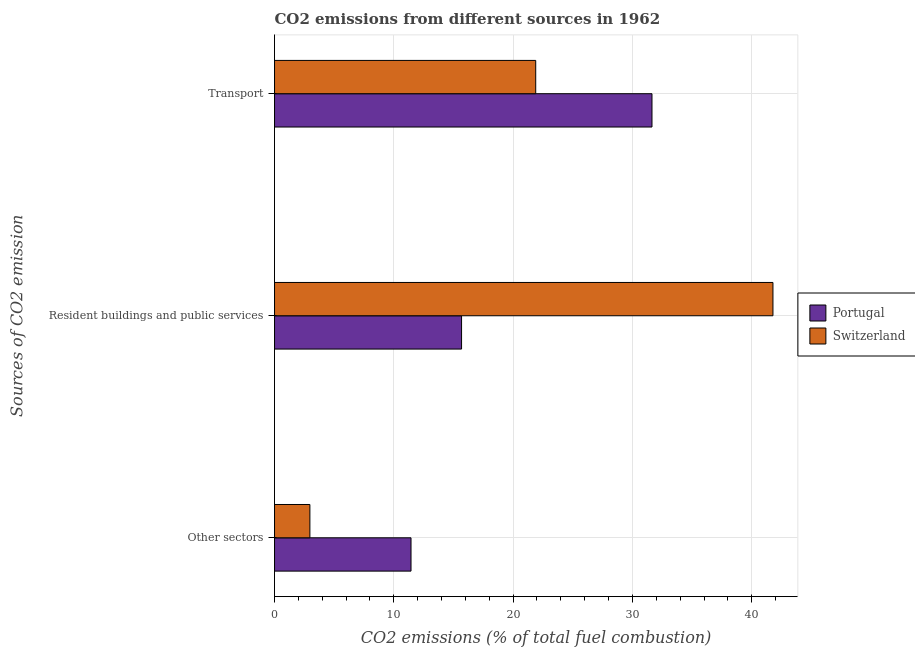Are the number of bars on each tick of the Y-axis equal?
Your answer should be compact. Yes. What is the label of the 3rd group of bars from the top?
Your answer should be compact. Other sectors. What is the percentage of co2 emissions from resident buildings and public services in Portugal?
Ensure brevity in your answer.  15.68. Across all countries, what is the maximum percentage of co2 emissions from other sectors?
Provide a succinct answer. 11.44. Across all countries, what is the minimum percentage of co2 emissions from resident buildings and public services?
Your answer should be very brief. 15.68. In which country was the percentage of co2 emissions from resident buildings and public services maximum?
Offer a terse response. Switzerland. In which country was the percentage of co2 emissions from transport minimum?
Provide a succinct answer. Switzerland. What is the total percentage of co2 emissions from other sectors in the graph?
Your response must be concise. 14.4. What is the difference between the percentage of co2 emissions from transport in Switzerland and that in Portugal?
Your response must be concise. -9.75. What is the difference between the percentage of co2 emissions from transport in Switzerland and the percentage of co2 emissions from other sectors in Portugal?
Make the answer very short. 10.45. What is the average percentage of co2 emissions from other sectors per country?
Your answer should be compact. 7.2. What is the difference between the percentage of co2 emissions from other sectors and percentage of co2 emissions from resident buildings and public services in Portugal?
Give a very brief answer. -4.24. What is the ratio of the percentage of co2 emissions from transport in Switzerland to that in Portugal?
Make the answer very short. 0.69. Is the percentage of co2 emissions from transport in Switzerland less than that in Portugal?
Your answer should be very brief. Yes. Is the difference between the percentage of co2 emissions from resident buildings and public services in Portugal and Switzerland greater than the difference between the percentage of co2 emissions from other sectors in Portugal and Switzerland?
Provide a short and direct response. No. What is the difference between the highest and the second highest percentage of co2 emissions from resident buildings and public services?
Your response must be concise. 26.1. What is the difference between the highest and the lowest percentage of co2 emissions from resident buildings and public services?
Provide a short and direct response. 26.1. In how many countries, is the percentage of co2 emissions from transport greater than the average percentage of co2 emissions from transport taken over all countries?
Ensure brevity in your answer.  1. Is the sum of the percentage of co2 emissions from resident buildings and public services in Portugal and Switzerland greater than the maximum percentage of co2 emissions from other sectors across all countries?
Offer a terse response. Yes. What does the 2nd bar from the top in Resident buildings and public services represents?
Make the answer very short. Portugal. What does the 1st bar from the bottom in Transport represents?
Give a very brief answer. Portugal. How many bars are there?
Your response must be concise. 6. Are all the bars in the graph horizontal?
Give a very brief answer. Yes. Are the values on the major ticks of X-axis written in scientific E-notation?
Provide a short and direct response. No. Where does the legend appear in the graph?
Your answer should be compact. Center right. How many legend labels are there?
Keep it short and to the point. 2. What is the title of the graph?
Give a very brief answer. CO2 emissions from different sources in 1962. Does "Slovenia" appear as one of the legend labels in the graph?
Give a very brief answer. No. What is the label or title of the X-axis?
Keep it short and to the point. CO2 emissions (% of total fuel combustion). What is the label or title of the Y-axis?
Offer a very short reply. Sources of CO2 emission. What is the CO2 emissions (% of total fuel combustion) of Portugal in Other sectors?
Your answer should be very brief. 11.44. What is the CO2 emissions (% of total fuel combustion) of Switzerland in Other sectors?
Ensure brevity in your answer.  2.96. What is the CO2 emissions (% of total fuel combustion) in Portugal in Resident buildings and public services?
Ensure brevity in your answer.  15.68. What is the CO2 emissions (% of total fuel combustion) in Switzerland in Resident buildings and public services?
Give a very brief answer. 41.78. What is the CO2 emissions (% of total fuel combustion) of Portugal in Transport?
Your answer should be compact. 31.64. What is the CO2 emissions (% of total fuel combustion) of Switzerland in Transport?
Provide a short and direct response. 21.89. Across all Sources of CO2 emission, what is the maximum CO2 emissions (% of total fuel combustion) in Portugal?
Ensure brevity in your answer.  31.64. Across all Sources of CO2 emission, what is the maximum CO2 emissions (% of total fuel combustion) of Switzerland?
Provide a short and direct response. 41.78. Across all Sources of CO2 emission, what is the minimum CO2 emissions (% of total fuel combustion) of Portugal?
Give a very brief answer. 11.44. Across all Sources of CO2 emission, what is the minimum CO2 emissions (% of total fuel combustion) in Switzerland?
Offer a terse response. 2.96. What is the total CO2 emissions (% of total fuel combustion) in Portugal in the graph?
Provide a short and direct response. 58.76. What is the total CO2 emissions (% of total fuel combustion) in Switzerland in the graph?
Provide a short and direct response. 66.63. What is the difference between the CO2 emissions (% of total fuel combustion) of Portugal in Other sectors and that in Resident buildings and public services?
Your response must be concise. -4.24. What is the difference between the CO2 emissions (% of total fuel combustion) in Switzerland in Other sectors and that in Resident buildings and public services?
Your response must be concise. -38.81. What is the difference between the CO2 emissions (% of total fuel combustion) in Portugal in Other sectors and that in Transport?
Your response must be concise. -20.2. What is the difference between the CO2 emissions (% of total fuel combustion) in Switzerland in Other sectors and that in Transport?
Offer a terse response. -18.93. What is the difference between the CO2 emissions (% of total fuel combustion) of Portugal in Resident buildings and public services and that in Transport?
Offer a very short reply. -15.96. What is the difference between the CO2 emissions (% of total fuel combustion) of Switzerland in Resident buildings and public services and that in Transport?
Provide a short and direct response. 19.89. What is the difference between the CO2 emissions (% of total fuel combustion) of Portugal in Other sectors and the CO2 emissions (% of total fuel combustion) of Switzerland in Resident buildings and public services?
Ensure brevity in your answer.  -30.34. What is the difference between the CO2 emissions (% of total fuel combustion) of Portugal in Other sectors and the CO2 emissions (% of total fuel combustion) of Switzerland in Transport?
Your answer should be compact. -10.45. What is the difference between the CO2 emissions (% of total fuel combustion) of Portugal in Resident buildings and public services and the CO2 emissions (% of total fuel combustion) of Switzerland in Transport?
Offer a very short reply. -6.21. What is the average CO2 emissions (% of total fuel combustion) in Portugal per Sources of CO2 emission?
Offer a terse response. 19.59. What is the average CO2 emissions (% of total fuel combustion) in Switzerland per Sources of CO2 emission?
Provide a short and direct response. 22.21. What is the difference between the CO2 emissions (% of total fuel combustion) of Portugal and CO2 emissions (% of total fuel combustion) of Switzerland in Other sectors?
Offer a terse response. 8.48. What is the difference between the CO2 emissions (% of total fuel combustion) in Portugal and CO2 emissions (% of total fuel combustion) in Switzerland in Resident buildings and public services?
Your response must be concise. -26.1. What is the difference between the CO2 emissions (% of total fuel combustion) of Portugal and CO2 emissions (% of total fuel combustion) of Switzerland in Transport?
Your answer should be compact. 9.75. What is the ratio of the CO2 emissions (% of total fuel combustion) of Portugal in Other sectors to that in Resident buildings and public services?
Provide a succinct answer. 0.73. What is the ratio of the CO2 emissions (% of total fuel combustion) in Switzerland in Other sectors to that in Resident buildings and public services?
Provide a short and direct response. 0.07. What is the ratio of the CO2 emissions (% of total fuel combustion) of Portugal in Other sectors to that in Transport?
Offer a terse response. 0.36. What is the ratio of the CO2 emissions (% of total fuel combustion) in Switzerland in Other sectors to that in Transport?
Keep it short and to the point. 0.14. What is the ratio of the CO2 emissions (% of total fuel combustion) in Portugal in Resident buildings and public services to that in Transport?
Provide a short and direct response. 0.5. What is the ratio of the CO2 emissions (% of total fuel combustion) in Switzerland in Resident buildings and public services to that in Transport?
Provide a short and direct response. 1.91. What is the difference between the highest and the second highest CO2 emissions (% of total fuel combustion) of Portugal?
Your answer should be very brief. 15.96. What is the difference between the highest and the second highest CO2 emissions (% of total fuel combustion) of Switzerland?
Provide a short and direct response. 19.89. What is the difference between the highest and the lowest CO2 emissions (% of total fuel combustion) of Portugal?
Provide a short and direct response. 20.2. What is the difference between the highest and the lowest CO2 emissions (% of total fuel combustion) in Switzerland?
Your response must be concise. 38.81. 